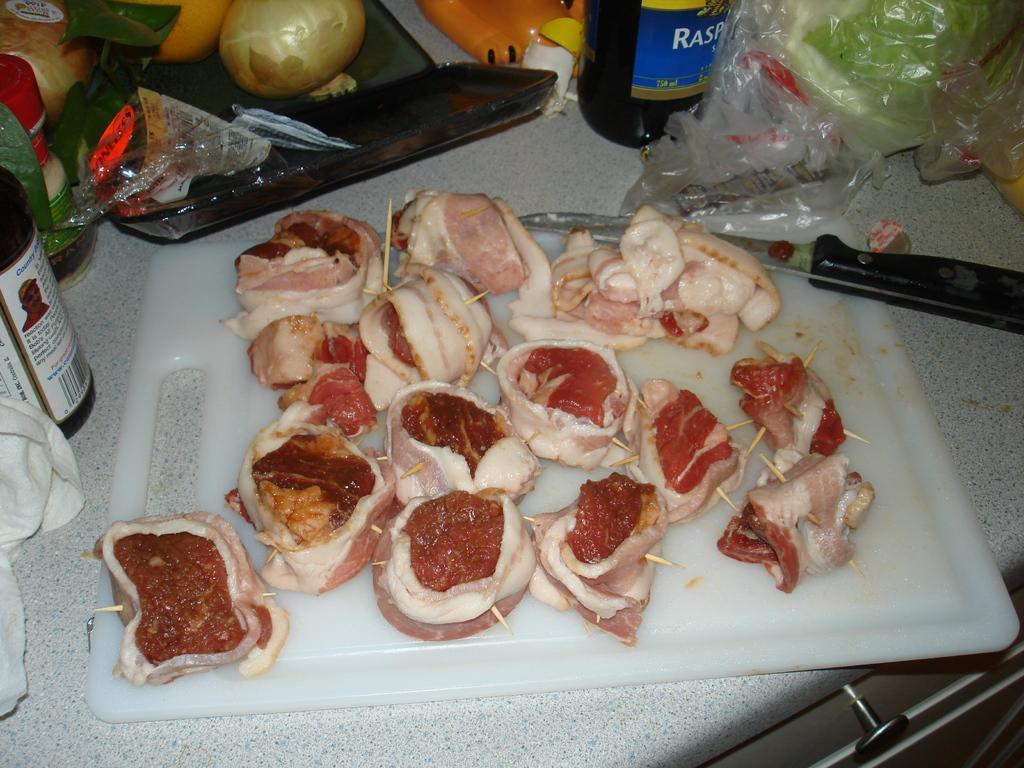Can you describe this image briefly? In this image I can see a white colour chopping board and on it I can see number of meat pieces and a knife. I can also see few bottles, few vegetables and few other things around the chopping board. 